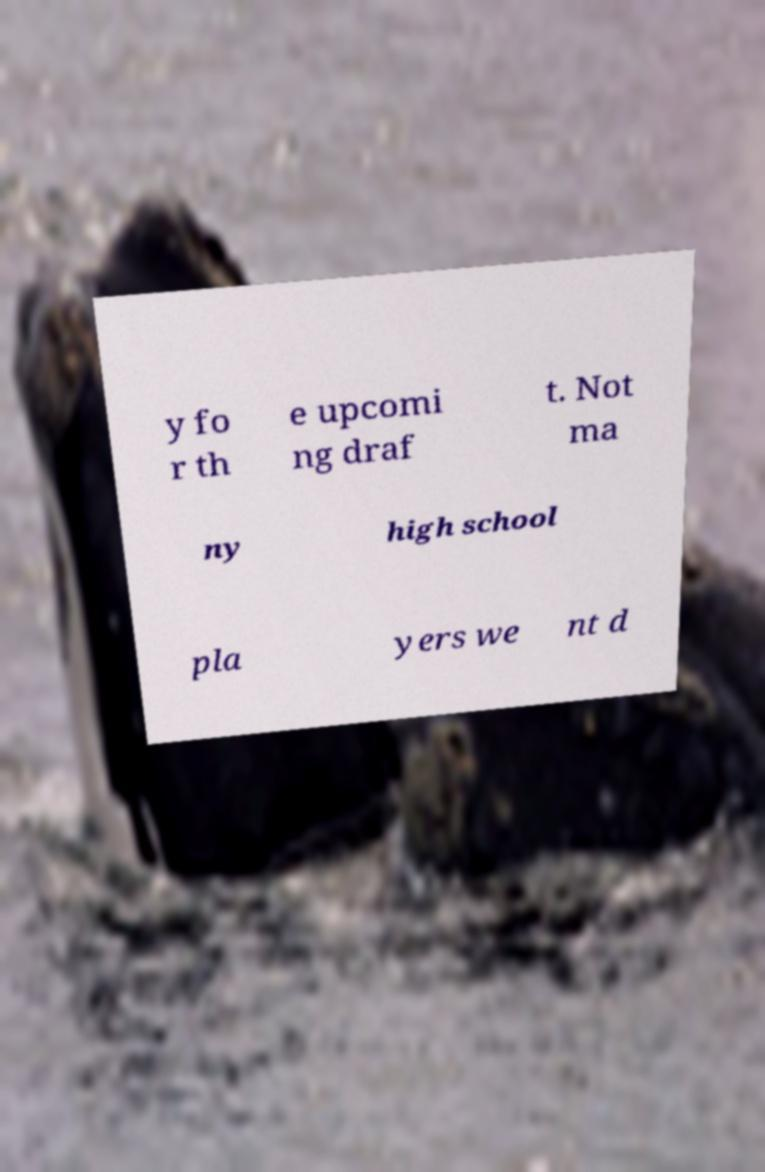For documentation purposes, I need the text within this image transcribed. Could you provide that? y fo r th e upcomi ng draf t. Not ma ny high school pla yers we nt d 